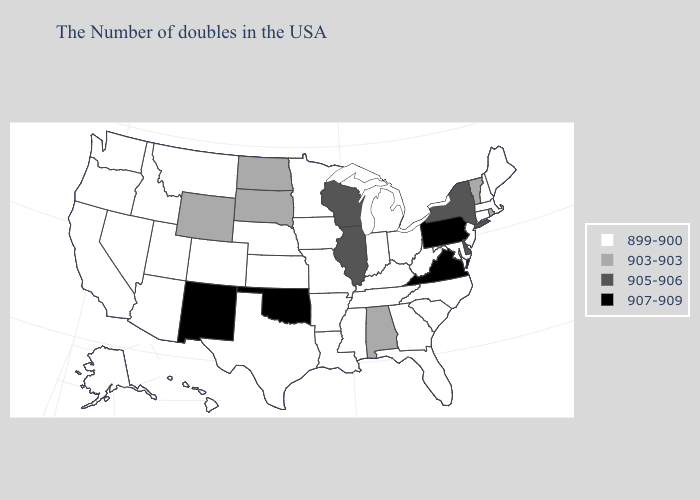Among the states that border Wisconsin , which have the lowest value?
Answer briefly. Michigan, Minnesota, Iowa. Name the states that have a value in the range 907-909?
Short answer required. Pennsylvania, Virginia, Oklahoma, New Mexico. Does Hawaii have a higher value than Texas?
Give a very brief answer. No. What is the value of Illinois?
Give a very brief answer. 905-906. Does Illinois have the same value as Arizona?
Answer briefly. No. Among the states that border Colorado , does New Mexico have the highest value?
Concise answer only. Yes. Does New Mexico have a higher value than Texas?
Short answer required. Yes. Name the states that have a value in the range 903-903?
Concise answer only. Rhode Island, Vermont, Alabama, South Dakota, North Dakota, Wyoming. Among the states that border Connecticut , does Massachusetts have the lowest value?
Concise answer only. Yes. What is the lowest value in the MidWest?
Concise answer only. 899-900. Among the states that border Ohio , does Kentucky have the highest value?
Write a very short answer. No. What is the highest value in the South ?
Write a very short answer. 907-909. Which states have the lowest value in the Northeast?
Keep it brief. Maine, Massachusetts, New Hampshire, Connecticut, New Jersey. What is the highest value in states that border Texas?
Answer briefly. 907-909. 